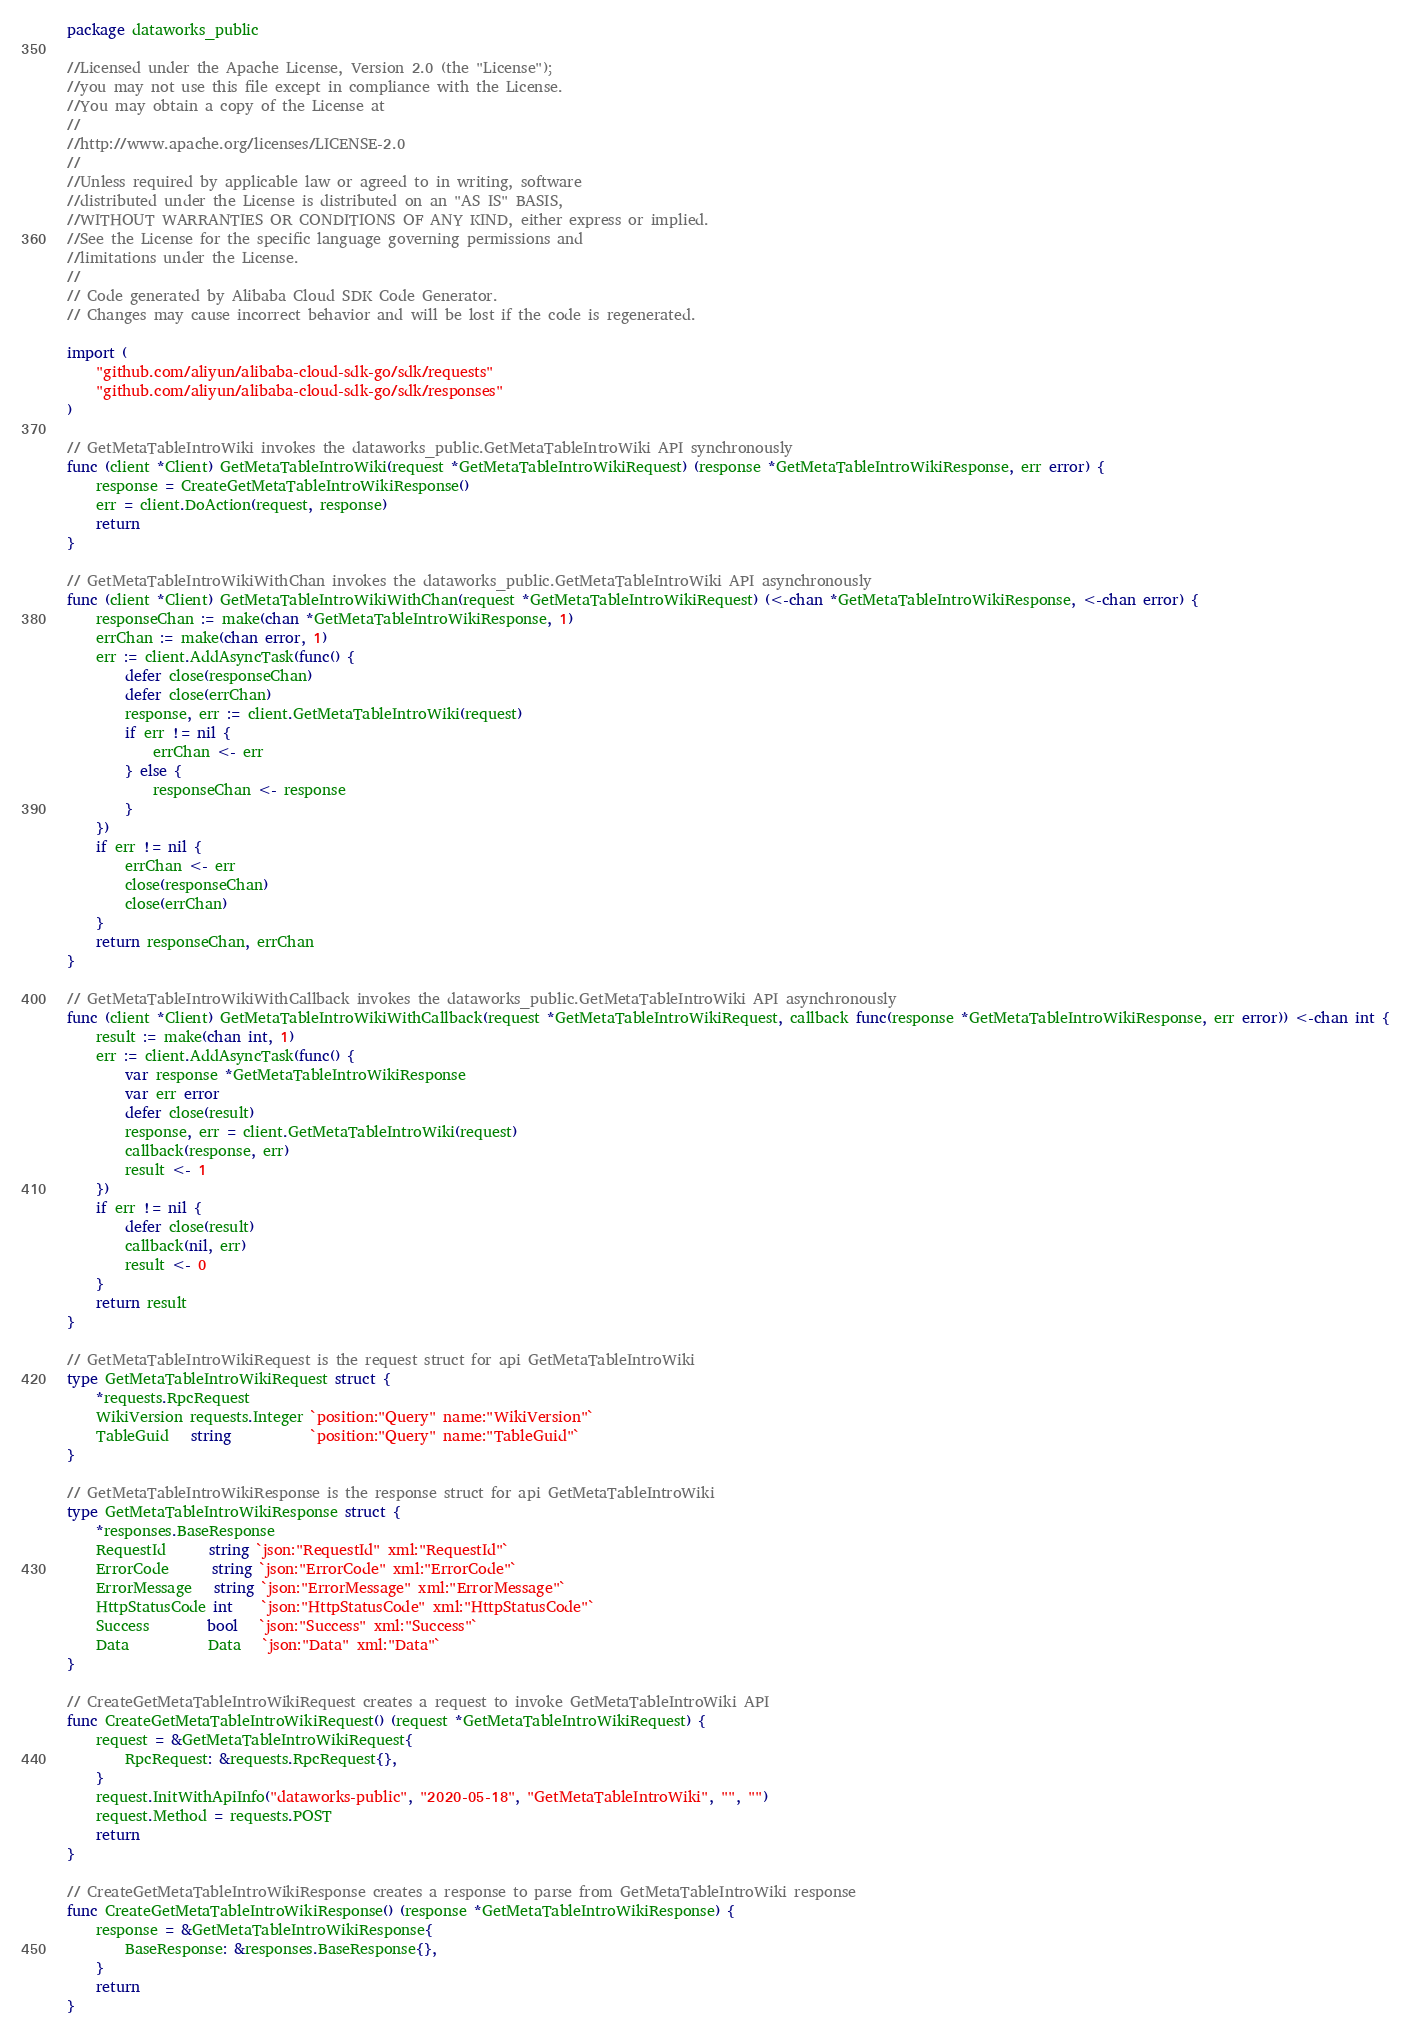<code> <loc_0><loc_0><loc_500><loc_500><_Go_>package dataworks_public

//Licensed under the Apache License, Version 2.0 (the "License");
//you may not use this file except in compliance with the License.
//You may obtain a copy of the License at
//
//http://www.apache.org/licenses/LICENSE-2.0
//
//Unless required by applicable law or agreed to in writing, software
//distributed under the License is distributed on an "AS IS" BASIS,
//WITHOUT WARRANTIES OR CONDITIONS OF ANY KIND, either express or implied.
//See the License for the specific language governing permissions and
//limitations under the License.
//
// Code generated by Alibaba Cloud SDK Code Generator.
// Changes may cause incorrect behavior and will be lost if the code is regenerated.

import (
	"github.com/aliyun/alibaba-cloud-sdk-go/sdk/requests"
	"github.com/aliyun/alibaba-cloud-sdk-go/sdk/responses"
)

// GetMetaTableIntroWiki invokes the dataworks_public.GetMetaTableIntroWiki API synchronously
func (client *Client) GetMetaTableIntroWiki(request *GetMetaTableIntroWikiRequest) (response *GetMetaTableIntroWikiResponse, err error) {
	response = CreateGetMetaTableIntroWikiResponse()
	err = client.DoAction(request, response)
	return
}

// GetMetaTableIntroWikiWithChan invokes the dataworks_public.GetMetaTableIntroWiki API asynchronously
func (client *Client) GetMetaTableIntroWikiWithChan(request *GetMetaTableIntroWikiRequest) (<-chan *GetMetaTableIntroWikiResponse, <-chan error) {
	responseChan := make(chan *GetMetaTableIntroWikiResponse, 1)
	errChan := make(chan error, 1)
	err := client.AddAsyncTask(func() {
		defer close(responseChan)
		defer close(errChan)
		response, err := client.GetMetaTableIntroWiki(request)
		if err != nil {
			errChan <- err
		} else {
			responseChan <- response
		}
	})
	if err != nil {
		errChan <- err
		close(responseChan)
		close(errChan)
	}
	return responseChan, errChan
}

// GetMetaTableIntroWikiWithCallback invokes the dataworks_public.GetMetaTableIntroWiki API asynchronously
func (client *Client) GetMetaTableIntroWikiWithCallback(request *GetMetaTableIntroWikiRequest, callback func(response *GetMetaTableIntroWikiResponse, err error)) <-chan int {
	result := make(chan int, 1)
	err := client.AddAsyncTask(func() {
		var response *GetMetaTableIntroWikiResponse
		var err error
		defer close(result)
		response, err = client.GetMetaTableIntroWiki(request)
		callback(response, err)
		result <- 1
	})
	if err != nil {
		defer close(result)
		callback(nil, err)
		result <- 0
	}
	return result
}

// GetMetaTableIntroWikiRequest is the request struct for api GetMetaTableIntroWiki
type GetMetaTableIntroWikiRequest struct {
	*requests.RpcRequest
	WikiVersion requests.Integer `position:"Query" name:"WikiVersion"`
	TableGuid   string           `position:"Query" name:"TableGuid"`
}

// GetMetaTableIntroWikiResponse is the response struct for api GetMetaTableIntroWiki
type GetMetaTableIntroWikiResponse struct {
	*responses.BaseResponse
	RequestId      string `json:"RequestId" xml:"RequestId"`
	ErrorCode      string `json:"ErrorCode" xml:"ErrorCode"`
	ErrorMessage   string `json:"ErrorMessage" xml:"ErrorMessage"`
	HttpStatusCode int    `json:"HttpStatusCode" xml:"HttpStatusCode"`
	Success        bool   `json:"Success" xml:"Success"`
	Data           Data   `json:"Data" xml:"Data"`
}

// CreateGetMetaTableIntroWikiRequest creates a request to invoke GetMetaTableIntroWiki API
func CreateGetMetaTableIntroWikiRequest() (request *GetMetaTableIntroWikiRequest) {
	request = &GetMetaTableIntroWikiRequest{
		RpcRequest: &requests.RpcRequest{},
	}
	request.InitWithApiInfo("dataworks-public", "2020-05-18", "GetMetaTableIntroWiki", "", "")
	request.Method = requests.POST
	return
}

// CreateGetMetaTableIntroWikiResponse creates a response to parse from GetMetaTableIntroWiki response
func CreateGetMetaTableIntroWikiResponse() (response *GetMetaTableIntroWikiResponse) {
	response = &GetMetaTableIntroWikiResponse{
		BaseResponse: &responses.BaseResponse{},
	}
	return
}
</code> 